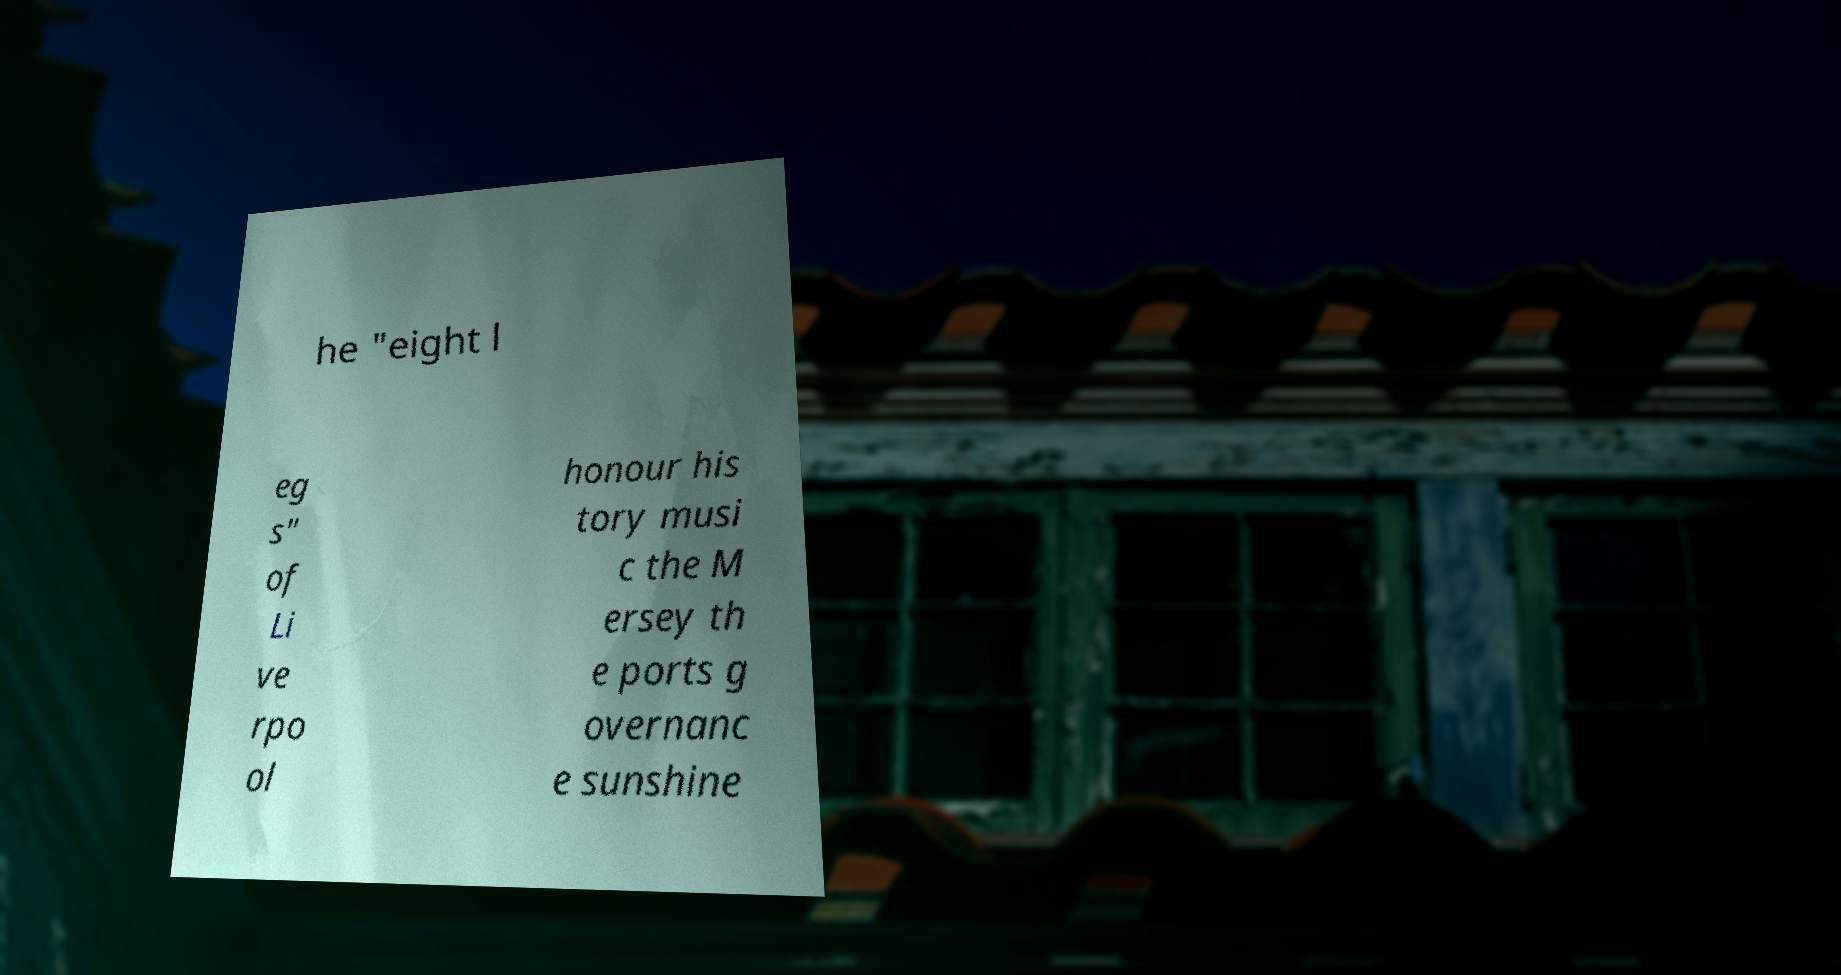I need the written content from this picture converted into text. Can you do that? he "eight l eg s" of Li ve rpo ol honour his tory musi c the M ersey th e ports g overnanc e sunshine 